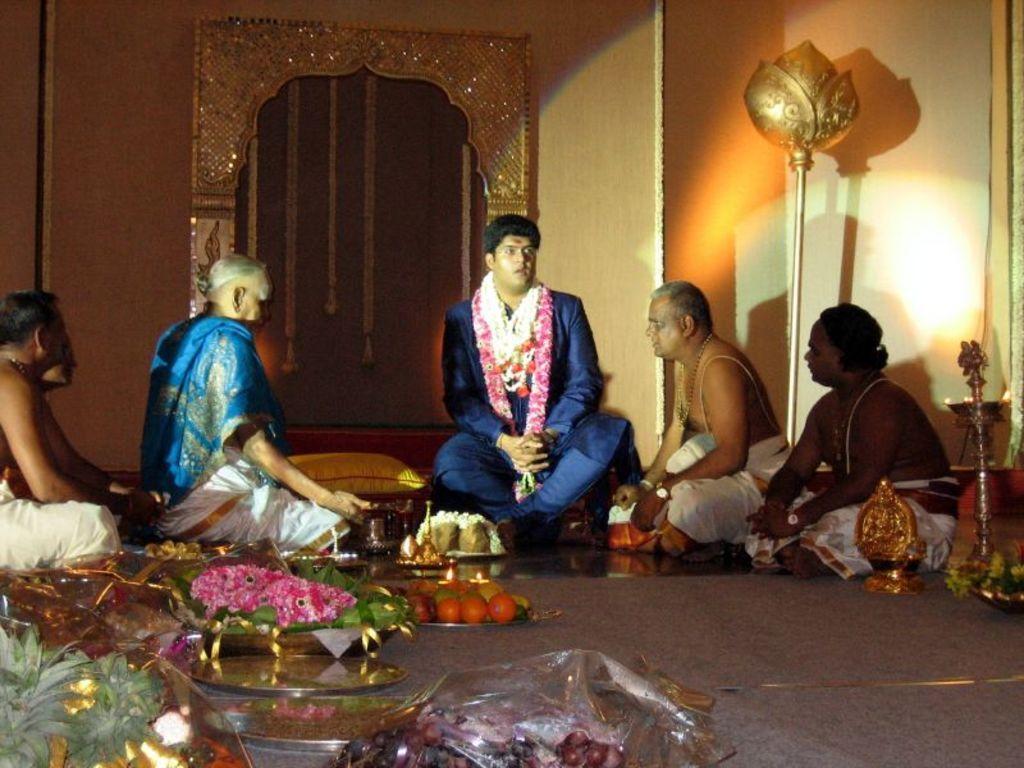Can you describe this image briefly? There is a person in gray color suit, wearing garland and sitting on a stool, along with other persons, who are sitting on the floor. There are fruits and other objects on the floor. In the background, there are garlands hanged, and there is a wall. 